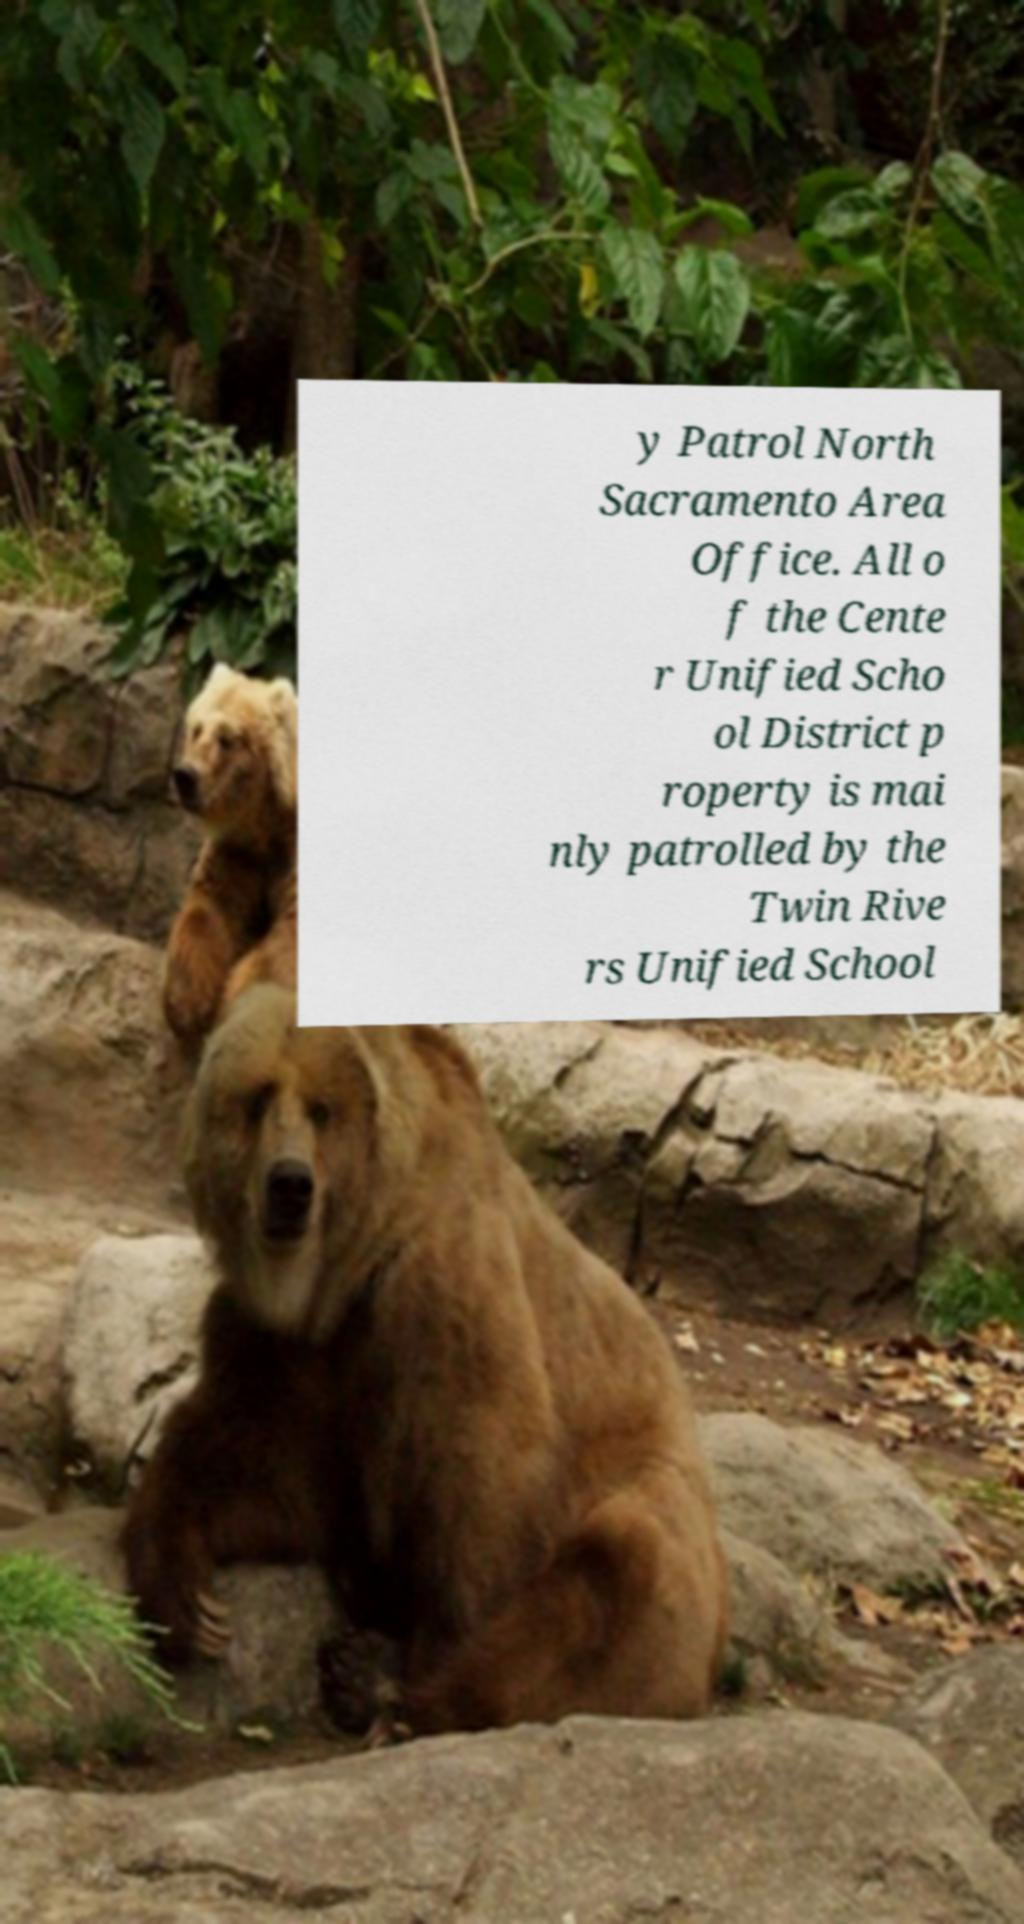Can you read and provide the text displayed in the image?This photo seems to have some interesting text. Can you extract and type it out for me? y Patrol North Sacramento Area Office. All o f the Cente r Unified Scho ol District p roperty is mai nly patrolled by the Twin Rive rs Unified School 